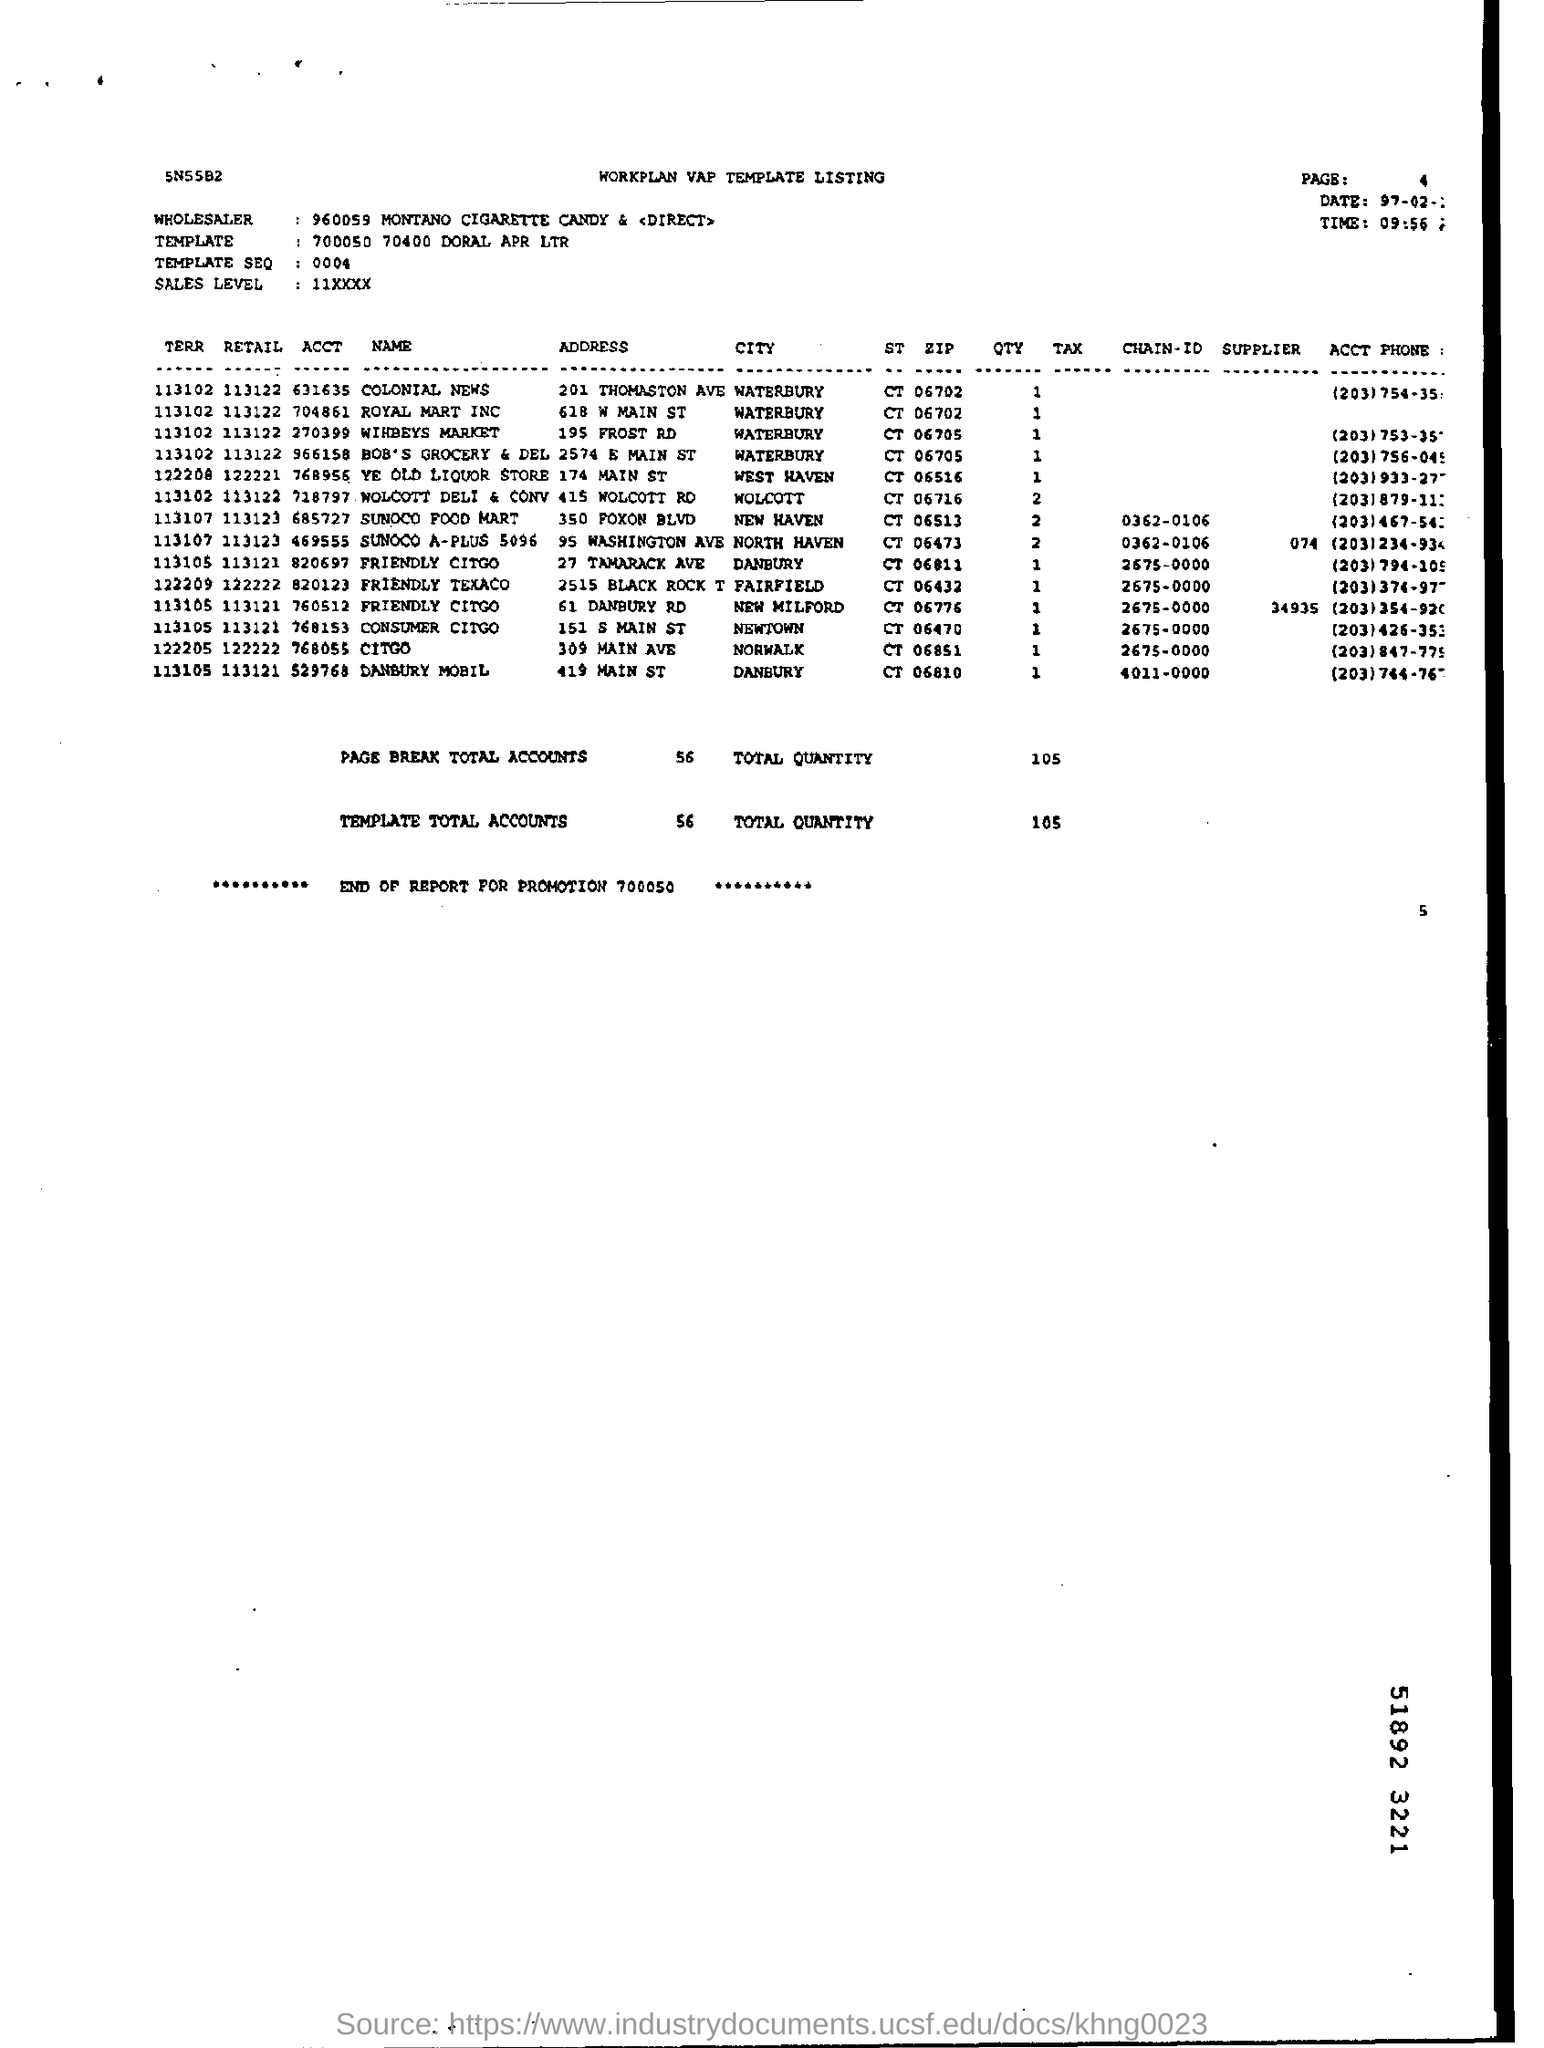What is the name of the wholesaler ?
Your answer should be very brief. 960059 MONTANO CIGARETTE CANDY & <DIRECT>. What is the time mentioned ?
Provide a short and direct response. 09:56 :. What is the template total accounts ?
Offer a very short reply. 56. What is the page break total accounts?
Keep it short and to the point. 56. 